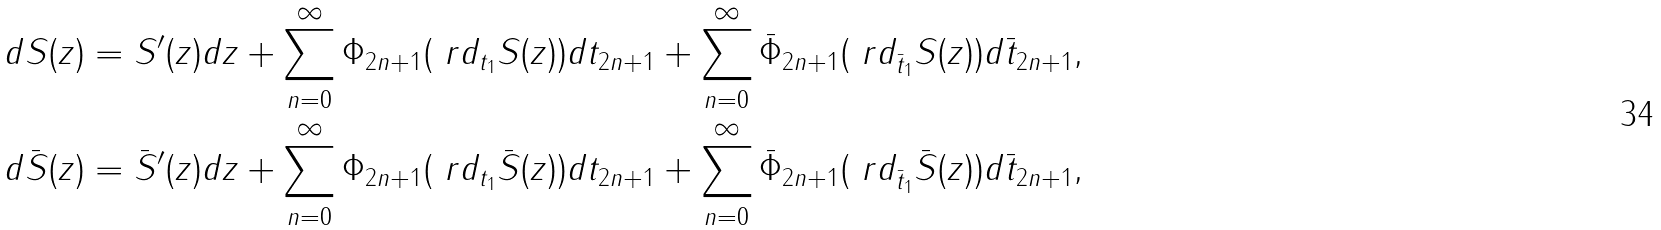Convert formula to latex. <formula><loc_0><loc_0><loc_500><loc_500>d S ( z ) = S ^ { \prime } ( z ) d z + \sum _ { n = 0 } ^ { \infty } \Phi _ { 2 n + 1 } ( \ r d _ { t _ { 1 } } S ( z ) ) d t _ { 2 n + 1 } + \sum _ { n = 0 } ^ { \infty } \bar { \Phi } _ { 2 n + 1 } ( \ r d _ { \bar { t } _ { 1 } } S ( z ) ) d \bar { t } _ { 2 n + 1 } , \\ d \bar { S } ( z ) = \bar { S } ^ { \prime } ( z ) d z + \sum _ { n = 0 } ^ { \infty } \Phi _ { 2 n + 1 } ( \ r d _ { t _ { 1 } } \bar { S } ( z ) ) d t _ { 2 n + 1 } + \sum _ { n = 0 } ^ { \infty } \bar { \Phi } _ { 2 n + 1 } ( \ r d _ { \bar { t } _ { 1 } } \bar { S } ( z ) ) d \bar { t } _ { 2 n + 1 } ,</formula> 